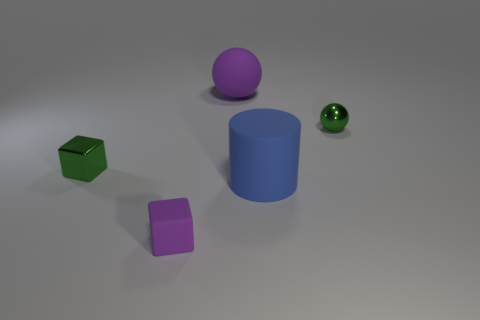Subtract all brown balls. Subtract all gray cylinders. How many balls are left? 2 Add 3 large cylinders. How many objects exist? 8 Subtract all cylinders. How many objects are left? 4 Add 5 big purple balls. How many big purple balls exist? 6 Subtract 0 gray blocks. How many objects are left? 5 Subtract all green metal balls. Subtract all tiny things. How many objects are left? 1 Add 4 large purple things. How many large purple things are left? 5 